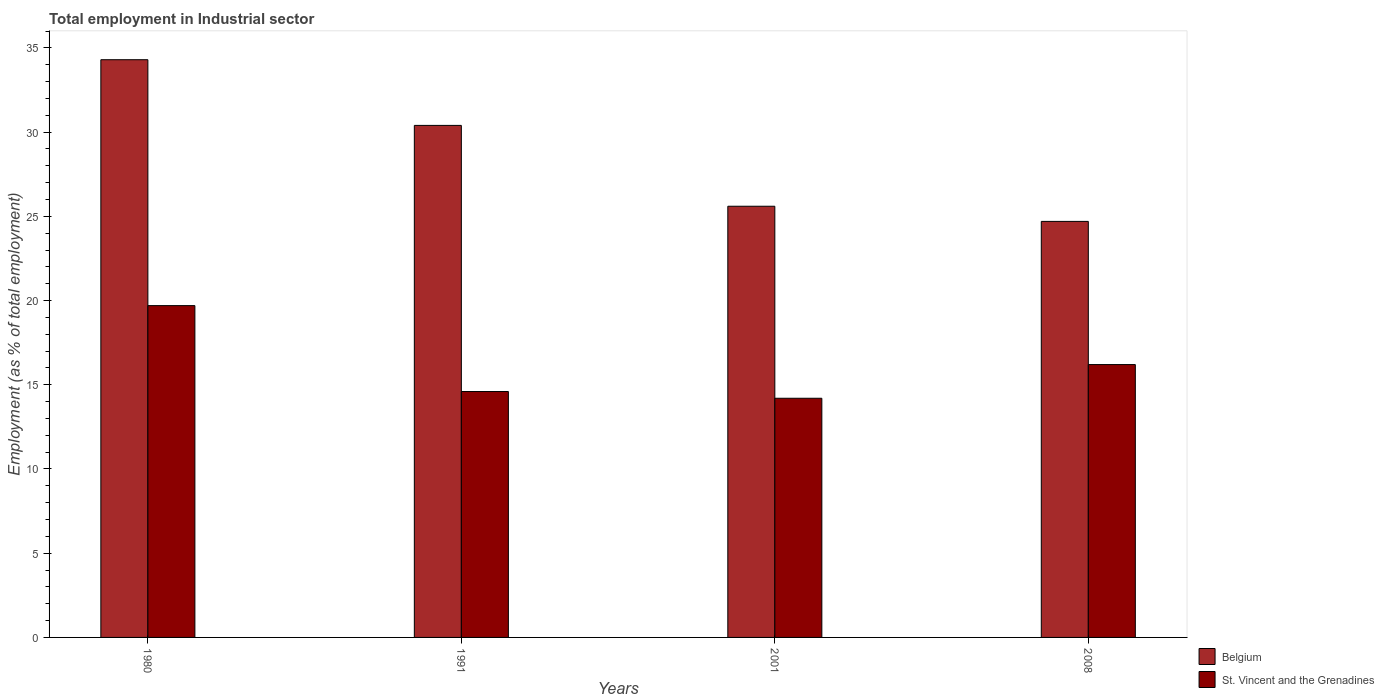Are the number of bars per tick equal to the number of legend labels?
Ensure brevity in your answer.  Yes. In how many cases, is the number of bars for a given year not equal to the number of legend labels?
Provide a succinct answer. 0. What is the employment in industrial sector in Belgium in 1991?
Offer a very short reply. 30.4. Across all years, what is the maximum employment in industrial sector in Belgium?
Your response must be concise. 34.3. Across all years, what is the minimum employment in industrial sector in Belgium?
Your answer should be compact. 24.7. What is the total employment in industrial sector in Belgium in the graph?
Keep it short and to the point. 115. What is the difference between the employment in industrial sector in Belgium in 1991 and that in 2008?
Keep it short and to the point. 5.7. What is the average employment in industrial sector in Belgium per year?
Provide a short and direct response. 28.75. In how many years, is the employment in industrial sector in Belgium greater than 25 %?
Your answer should be very brief. 3. What is the ratio of the employment in industrial sector in Belgium in 1991 to that in 2001?
Keep it short and to the point. 1.19. Is the employment in industrial sector in St. Vincent and the Grenadines in 1980 less than that in 1991?
Your response must be concise. No. What is the difference between the highest and the second highest employment in industrial sector in Belgium?
Your response must be concise. 3.9. What is the difference between the highest and the lowest employment in industrial sector in Belgium?
Your response must be concise. 9.6. Is the sum of the employment in industrial sector in Belgium in 1980 and 2008 greater than the maximum employment in industrial sector in St. Vincent and the Grenadines across all years?
Give a very brief answer. Yes. What does the 2nd bar from the left in 2008 represents?
Offer a terse response. St. Vincent and the Grenadines. What does the 1st bar from the right in 1991 represents?
Keep it short and to the point. St. Vincent and the Grenadines. Are all the bars in the graph horizontal?
Make the answer very short. No. How many years are there in the graph?
Your answer should be compact. 4. Does the graph contain grids?
Keep it short and to the point. No. How many legend labels are there?
Ensure brevity in your answer.  2. How are the legend labels stacked?
Make the answer very short. Vertical. What is the title of the graph?
Your answer should be compact. Total employment in Industrial sector. Does "OECD members" appear as one of the legend labels in the graph?
Make the answer very short. No. What is the label or title of the Y-axis?
Provide a short and direct response. Employment (as % of total employment). What is the Employment (as % of total employment) of Belgium in 1980?
Ensure brevity in your answer.  34.3. What is the Employment (as % of total employment) of St. Vincent and the Grenadines in 1980?
Your answer should be compact. 19.7. What is the Employment (as % of total employment) in Belgium in 1991?
Your answer should be very brief. 30.4. What is the Employment (as % of total employment) of St. Vincent and the Grenadines in 1991?
Keep it short and to the point. 14.6. What is the Employment (as % of total employment) of Belgium in 2001?
Your answer should be very brief. 25.6. What is the Employment (as % of total employment) of St. Vincent and the Grenadines in 2001?
Provide a short and direct response. 14.2. What is the Employment (as % of total employment) in Belgium in 2008?
Provide a short and direct response. 24.7. What is the Employment (as % of total employment) of St. Vincent and the Grenadines in 2008?
Keep it short and to the point. 16.2. Across all years, what is the maximum Employment (as % of total employment) in Belgium?
Offer a very short reply. 34.3. Across all years, what is the maximum Employment (as % of total employment) in St. Vincent and the Grenadines?
Provide a succinct answer. 19.7. Across all years, what is the minimum Employment (as % of total employment) in Belgium?
Your response must be concise. 24.7. Across all years, what is the minimum Employment (as % of total employment) in St. Vincent and the Grenadines?
Offer a very short reply. 14.2. What is the total Employment (as % of total employment) in Belgium in the graph?
Your answer should be very brief. 115. What is the total Employment (as % of total employment) of St. Vincent and the Grenadines in the graph?
Give a very brief answer. 64.7. What is the difference between the Employment (as % of total employment) in Belgium in 1980 and that in 1991?
Keep it short and to the point. 3.9. What is the difference between the Employment (as % of total employment) in St. Vincent and the Grenadines in 1980 and that in 1991?
Provide a short and direct response. 5.1. What is the difference between the Employment (as % of total employment) of Belgium in 1980 and that in 2001?
Ensure brevity in your answer.  8.7. What is the difference between the Employment (as % of total employment) in St. Vincent and the Grenadines in 1980 and that in 2001?
Keep it short and to the point. 5.5. What is the difference between the Employment (as % of total employment) of Belgium in 1980 and that in 2008?
Your answer should be very brief. 9.6. What is the difference between the Employment (as % of total employment) in St. Vincent and the Grenadines in 1980 and that in 2008?
Offer a terse response. 3.5. What is the difference between the Employment (as % of total employment) of Belgium in 1991 and that in 2001?
Your response must be concise. 4.8. What is the difference between the Employment (as % of total employment) of Belgium in 2001 and that in 2008?
Make the answer very short. 0.9. What is the difference between the Employment (as % of total employment) of St. Vincent and the Grenadines in 2001 and that in 2008?
Provide a succinct answer. -2. What is the difference between the Employment (as % of total employment) in Belgium in 1980 and the Employment (as % of total employment) in St. Vincent and the Grenadines in 1991?
Make the answer very short. 19.7. What is the difference between the Employment (as % of total employment) of Belgium in 1980 and the Employment (as % of total employment) of St. Vincent and the Grenadines in 2001?
Give a very brief answer. 20.1. What is the difference between the Employment (as % of total employment) of Belgium in 1980 and the Employment (as % of total employment) of St. Vincent and the Grenadines in 2008?
Make the answer very short. 18.1. What is the difference between the Employment (as % of total employment) in Belgium in 1991 and the Employment (as % of total employment) in St. Vincent and the Grenadines in 2008?
Give a very brief answer. 14.2. What is the difference between the Employment (as % of total employment) of Belgium in 2001 and the Employment (as % of total employment) of St. Vincent and the Grenadines in 2008?
Keep it short and to the point. 9.4. What is the average Employment (as % of total employment) in Belgium per year?
Offer a terse response. 28.75. What is the average Employment (as % of total employment) in St. Vincent and the Grenadines per year?
Offer a terse response. 16.18. In the year 1980, what is the difference between the Employment (as % of total employment) in Belgium and Employment (as % of total employment) in St. Vincent and the Grenadines?
Make the answer very short. 14.6. In the year 1991, what is the difference between the Employment (as % of total employment) in Belgium and Employment (as % of total employment) in St. Vincent and the Grenadines?
Make the answer very short. 15.8. In the year 2001, what is the difference between the Employment (as % of total employment) of Belgium and Employment (as % of total employment) of St. Vincent and the Grenadines?
Your response must be concise. 11.4. What is the ratio of the Employment (as % of total employment) in Belgium in 1980 to that in 1991?
Keep it short and to the point. 1.13. What is the ratio of the Employment (as % of total employment) in St. Vincent and the Grenadines in 1980 to that in 1991?
Your answer should be compact. 1.35. What is the ratio of the Employment (as % of total employment) of Belgium in 1980 to that in 2001?
Make the answer very short. 1.34. What is the ratio of the Employment (as % of total employment) of St. Vincent and the Grenadines in 1980 to that in 2001?
Your answer should be compact. 1.39. What is the ratio of the Employment (as % of total employment) of Belgium in 1980 to that in 2008?
Give a very brief answer. 1.39. What is the ratio of the Employment (as % of total employment) in St. Vincent and the Grenadines in 1980 to that in 2008?
Your answer should be compact. 1.22. What is the ratio of the Employment (as % of total employment) of Belgium in 1991 to that in 2001?
Provide a short and direct response. 1.19. What is the ratio of the Employment (as % of total employment) of St. Vincent and the Grenadines in 1991 to that in 2001?
Keep it short and to the point. 1.03. What is the ratio of the Employment (as % of total employment) in Belgium in 1991 to that in 2008?
Give a very brief answer. 1.23. What is the ratio of the Employment (as % of total employment) in St. Vincent and the Grenadines in 1991 to that in 2008?
Your answer should be very brief. 0.9. What is the ratio of the Employment (as % of total employment) in Belgium in 2001 to that in 2008?
Give a very brief answer. 1.04. What is the ratio of the Employment (as % of total employment) of St. Vincent and the Grenadines in 2001 to that in 2008?
Make the answer very short. 0.88. What is the difference between the highest and the lowest Employment (as % of total employment) in Belgium?
Ensure brevity in your answer.  9.6. 